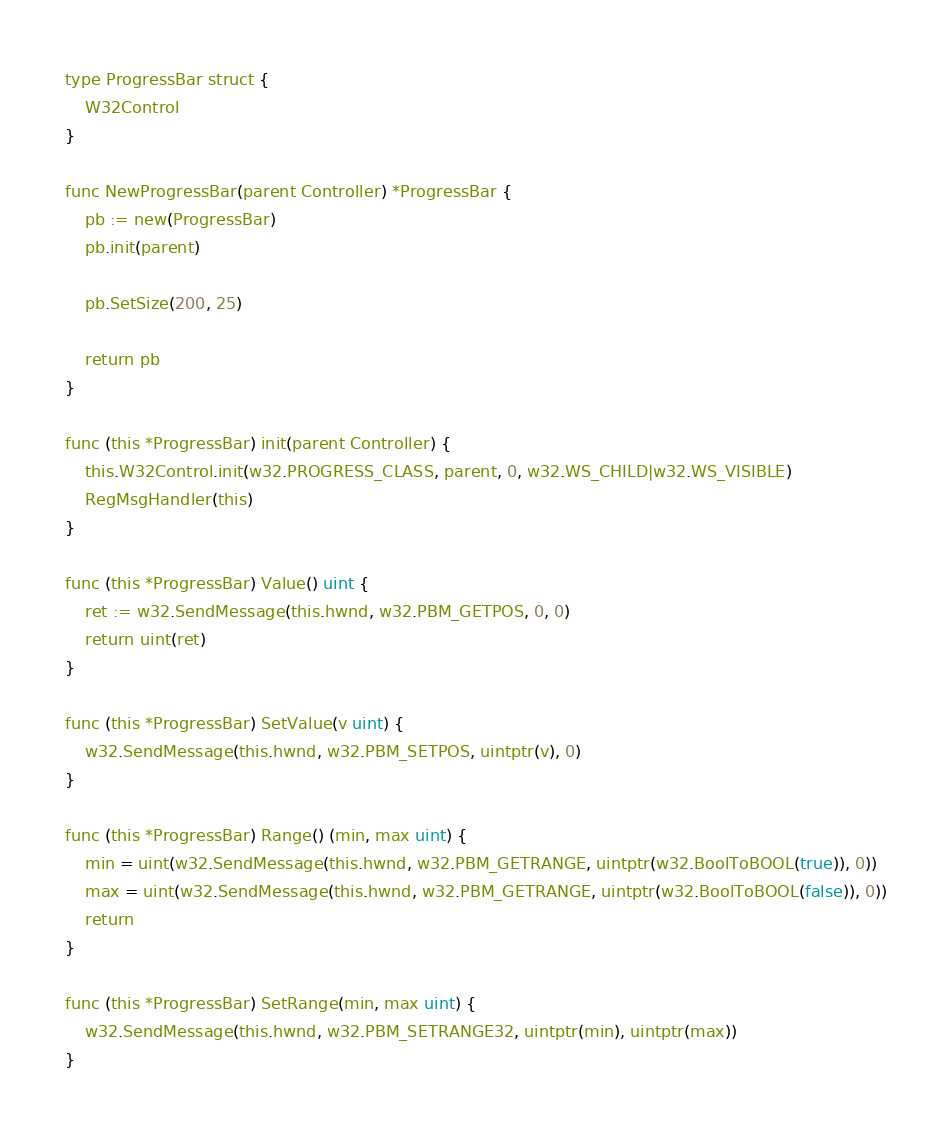<code> <loc_0><loc_0><loc_500><loc_500><_Go_>
type ProgressBar struct {
    W32Control
}

func NewProgressBar(parent Controller) *ProgressBar {
    pb := new(ProgressBar)
    pb.init(parent)

    pb.SetSize(200, 25)

    return pb
}

func (this *ProgressBar) init(parent Controller) {
    this.W32Control.init(w32.PROGRESS_CLASS, parent, 0, w32.WS_CHILD|w32.WS_VISIBLE)
    RegMsgHandler(this)
}

func (this *ProgressBar) Value() uint {
    ret := w32.SendMessage(this.hwnd, w32.PBM_GETPOS, 0, 0)
    return uint(ret)
}

func (this *ProgressBar) SetValue(v uint) {
    w32.SendMessage(this.hwnd, w32.PBM_SETPOS, uintptr(v), 0)
}

func (this *ProgressBar) Range() (min, max uint) {
    min = uint(w32.SendMessage(this.hwnd, w32.PBM_GETRANGE, uintptr(w32.BoolToBOOL(true)), 0))
    max = uint(w32.SendMessage(this.hwnd, w32.PBM_GETRANGE, uintptr(w32.BoolToBOOL(false)), 0))
    return
}

func (this *ProgressBar) SetRange(min, max uint) {
    w32.SendMessage(this.hwnd, w32.PBM_SETRANGE32, uintptr(min), uintptr(max))
}
</code> 